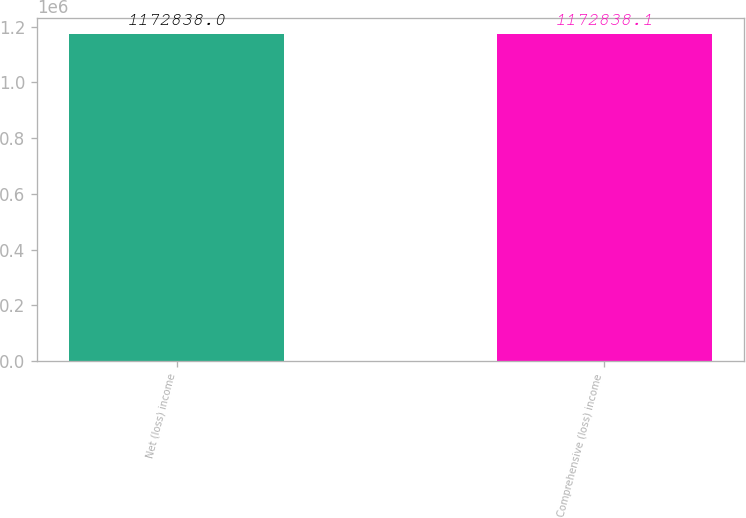Convert chart. <chart><loc_0><loc_0><loc_500><loc_500><bar_chart><fcel>Net (loss) income<fcel>Comprehensive (loss) income<nl><fcel>1.17284e+06<fcel>1.17284e+06<nl></chart> 